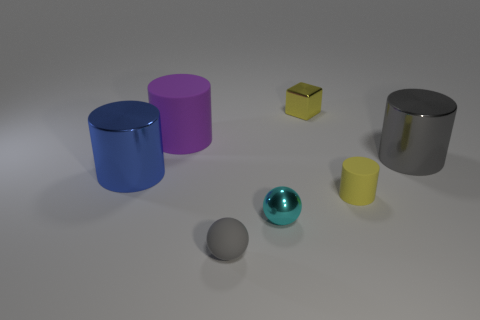Which objects seem closest to the light source, and how can you tell? The cyan shiny sphere and the blue metallic cylinder appear to be closest to the light source. This is indicated by the bright highlights and strong contrasts on their surfaces, suggesting the light is hitting them more directly compared to the other objects. The intensity of the reflections and the distinct shadow edges further imply their proximity to the light source. 